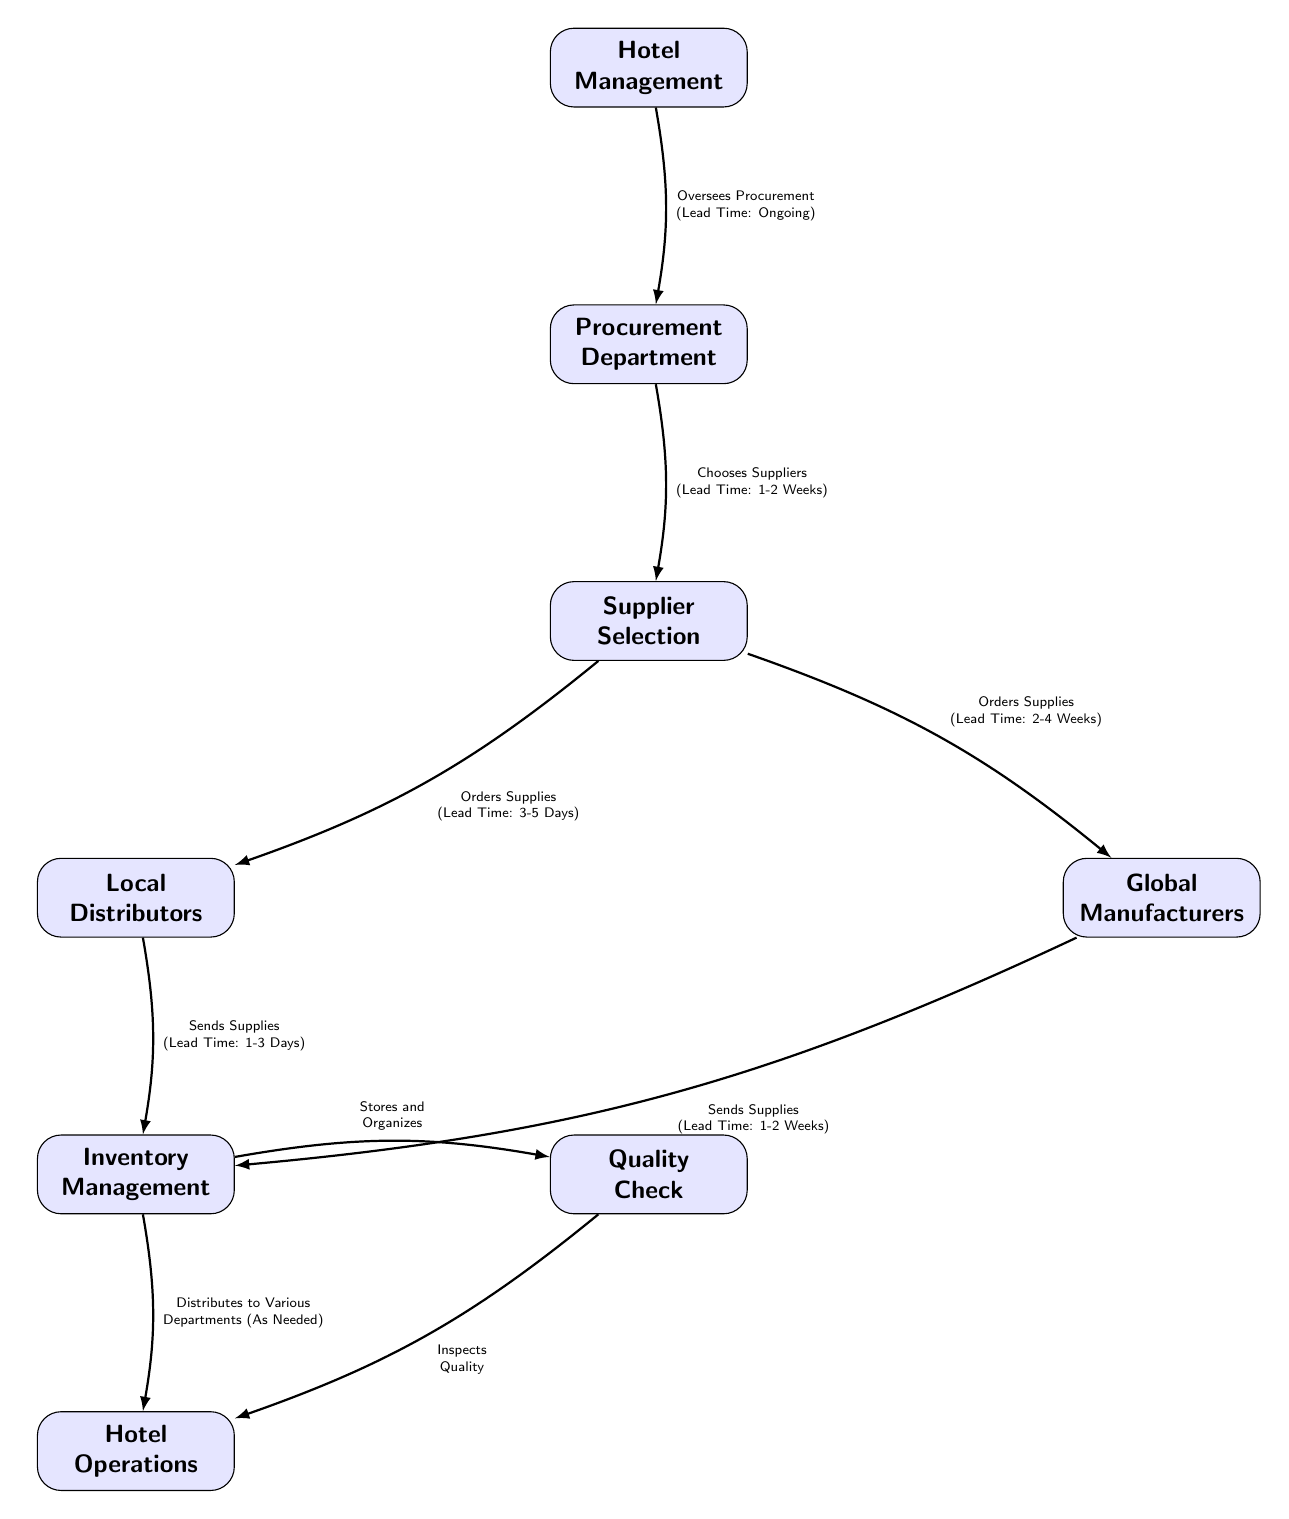What is the lead time for choosing suppliers? The diagram indicates that the lead time for choosing suppliers is 1-2 Weeks as specified in the edge connecting the Procurement Department and Supplier Selection.
Answer: 1-2 Weeks How many total nodes are present in the diagram? By counting each labeled block, we identify a total of eight nodes: Hotel Management, Procurement Department, Supplier Selection, Local Distributors, Global Manufacturers, Inventory Management, Quality Check, and Hotel Operations.
Answer: 8 What does the Inventory Management node connect to? The Inventory Management node connects to two nodes: Quality Check and Hotel Operations, as indicated by the arrows leading out from the Inventory Management node.
Answer: Quality Check and Hotel Operations What is the relationship between Supplier Selection and Local Distributors? Supplier Selection is related to Local Distributors through the action "Orders Supplies" with the corresponding lead time of 3-5 Days, as illustrated by the directed edge connecting these two nodes.
Answer: Orders Supplies (Lead Time: 3-5 Days) Which node oversees the procurement process? The diagram clearly outlines that the Hotel Management node oversees procurement, which is indicated by the arrow going from Hotel Management to Procurement Department stating "Oversees Procurement (Lead Time: Ongoing)".
Answer: Hotel Management What is the lead time for supplies sent from Global Manufacturers to Inventory Management? According to the diagram, the lead time for supplies sent from Global Manufacturers to Inventory Management is specified as 1-2 Weeks, which is shown on the edge connecting these two nodes.
Answer: 1-2 Weeks What is the final step in the supply chain process? The final step in the supply chain process is Hotel Operations, which receives supplies either from the Quality Check or directly from Inventory Management, as depicted in the arrows leading to the Hotel Operations node.
Answer: Hotel Operations What function does the Quality Check node serve? The Quality Check node serves the function of inspecting the quality of supplies as indicated by the label on the arrow leading to the Hotel Operations node.
Answer: Inspects Quality 